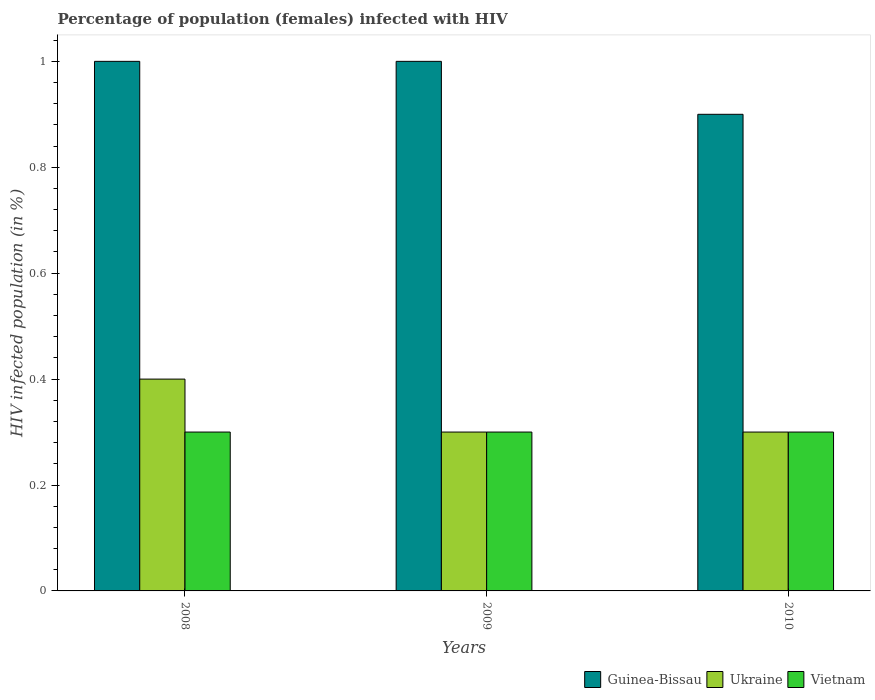How many different coloured bars are there?
Provide a succinct answer. 3. How many groups of bars are there?
Make the answer very short. 3. Are the number of bars per tick equal to the number of legend labels?
Ensure brevity in your answer.  Yes. What is the label of the 1st group of bars from the left?
Your response must be concise. 2008. In how many cases, is the number of bars for a given year not equal to the number of legend labels?
Provide a short and direct response. 0. In which year was the percentage of HIV infected female population in Ukraine maximum?
Offer a very short reply. 2008. What is the total percentage of HIV infected female population in Ukraine in the graph?
Provide a short and direct response. 1. What is the average percentage of HIV infected female population in Ukraine per year?
Offer a very short reply. 0.33. In the year 2009, what is the difference between the percentage of HIV infected female population in Guinea-Bissau and percentage of HIV infected female population in Ukraine?
Offer a terse response. 0.7. What is the ratio of the percentage of HIV infected female population in Guinea-Bissau in 2008 to that in 2009?
Your answer should be very brief. 1. Is the percentage of HIV infected female population in Ukraine in 2008 less than that in 2010?
Your answer should be very brief. No. What is the difference between the highest and the lowest percentage of HIV infected female population in Guinea-Bissau?
Your answer should be compact. 0.1. In how many years, is the percentage of HIV infected female population in Ukraine greater than the average percentage of HIV infected female population in Ukraine taken over all years?
Provide a succinct answer. 1. What does the 3rd bar from the left in 2008 represents?
Ensure brevity in your answer.  Vietnam. What does the 1st bar from the right in 2008 represents?
Your answer should be compact. Vietnam. How many bars are there?
Provide a succinct answer. 9. Are all the bars in the graph horizontal?
Offer a very short reply. No. How many years are there in the graph?
Your response must be concise. 3. What is the difference between two consecutive major ticks on the Y-axis?
Your answer should be very brief. 0.2. Are the values on the major ticks of Y-axis written in scientific E-notation?
Your answer should be compact. No. Does the graph contain any zero values?
Give a very brief answer. No. Does the graph contain grids?
Offer a very short reply. No. Where does the legend appear in the graph?
Offer a very short reply. Bottom right. What is the title of the graph?
Ensure brevity in your answer.  Percentage of population (females) infected with HIV. Does "El Salvador" appear as one of the legend labels in the graph?
Make the answer very short. No. What is the label or title of the X-axis?
Your answer should be compact. Years. What is the label or title of the Y-axis?
Provide a succinct answer. HIV infected population (in %). What is the HIV infected population (in %) of Guinea-Bissau in 2008?
Provide a short and direct response. 1. What is the HIV infected population (in %) of Ukraine in 2008?
Offer a terse response. 0.4. What is the HIV infected population (in %) in Vietnam in 2008?
Give a very brief answer. 0.3. What is the HIV infected population (in %) in Guinea-Bissau in 2009?
Keep it short and to the point. 1. What is the HIV infected population (in %) of Ukraine in 2009?
Your response must be concise. 0.3. What is the HIV infected population (in %) in Guinea-Bissau in 2010?
Your answer should be compact. 0.9. What is the HIV infected population (in %) of Vietnam in 2010?
Your answer should be very brief. 0.3. Across all years, what is the maximum HIV infected population (in %) of Guinea-Bissau?
Ensure brevity in your answer.  1. Across all years, what is the maximum HIV infected population (in %) in Ukraine?
Keep it short and to the point. 0.4. Across all years, what is the maximum HIV infected population (in %) in Vietnam?
Provide a short and direct response. 0.3. Across all years, what is the minimum HIV infected population (in %) of Guinea-Bissau?
Offer a terse response. 0.9. Across all years, what is the minimum HIV infected population (in %) of Vietnam?
Ensure brevity in your answer.  0.3. What is the total HIV infected population (in %) of Guinea-Bissau in the graph?
Keep it short and to the point. 2.9. What is the total HIV infected population (in %) in Ukraine in the graph?
Keep it short and to the point. 1. What is the total HIV infected population (in %) in Vietnam in the graph?
Ensure brevity in your answer.  0.9. What is the difference between the HIV infected population (in %) in Ukraine in 2008 and that in 2009?
Your answer should be very brief. 0.1. What is the difference between the HIV infected population (in %) in Vietnam in 2008 and that in 2009?
Your response must be concise. 0. What is the difference between the HIV infected population (in %) in Vietnam in 2008 and that in 2010?
Your answer should be compact. 0. What is the difference between the HIV infected population (in %) in Guinea-Bissau in 2009 and that in 2010?
Provide a short and direct response. 0.1. What is the difference between the HIV infected population (in %) of Ukraine in 2009 and that in 2010?
Your answer should be compact. 0. What is the difference between the HIV infected population (in %) in Guinea-Bissau in 2008 and the HIV infected population (in %) in Vietnam in 2009?
Your response must be concise. 0.7. What is the difference between the HIV infected population (in %) of Guinea-Bissau in 2009 and the HIV infected population (in %) of Ukraine in 2010?
Give a very brief answer. 0.7. What is the difference between the HIV infected population (in %) in Guinea-Bissau in 2009 and the HIV infected population (in %) in Vietnam in 2010?
Your response must be concise. 0.7. What is the difference between the HIV infected population (in %) in Ukraine in 2009 and the HIV infected population (in %) in Vietnam in 2010?
Give a very brief answer. 0. What is the average HIV infected population (in %) in Guinea-Bissau per year?
Your answer should be compact. 0.97. What is the average HIV infected population (in %) of Vietnam per year?
Your response must be concise. 0.3. In the year 2008, what is the difference between the HIV infected population (in %) in Ukraine and HIV infected population (in %) in Vietnam?
Offer a very short reply. 0.1. In the year 2009, what is the difference between the HIV infected population (in %) of Guinea-Bissau and HIV infected population (in %) of Ukraine?
Keep it short and to the point. 0.7. In the year 2009, what is the difference between the HIV infected population (in %) of Ukraine and HIV infected population (in %) of Vietnam?
Give a very brief answer. 0. In the year 2010, what is the difference between the HIV infected population (in %) in Guinea-Bissau and HIV infected population (in %) in Ukraine?
Give a very brief answer. 0.6. What is the ratio of the HIV infected population (in %) of Guinea-Bissau in 2008 to that in 2009?
Ensure brevity in your answer.  1. What is the ratio of the HIV infected population (in %) of Ukraine in 2008 to that in 2009?
Provide a succinct answer. 1.33. What is the ratio of the HIV infected population (in %) of Vietnam in 2008 to that in 2009?
Make the answer very short. 1. What is the ratio of the HIV infected population (in %) of Guinea-Bissau in 2008 to that in 2010?
Offer a very short reply. 1.11. What is the ratio of the HIV infected population (in %) of Vietnam in 2008 to that in 2010?
Give a very brief answer. 1. What is the ratio of the HIV infected population (in %) of Guinea-Bissau in 2009 to that in 2010?
Offer a terse response. 1.11. What is the ratio of the HIV infected population (in %) of Vietnam in 2009 to that in 2010?
Provide a short and direct response. 1. What is the difference between the highest and the second highest HIV infected population (in %) of Guinea-Bissau?
Your answer should be very brief. 0. What is the difference between the highest and the second highest HIV infected population (in %) of Ukraine?
Your answer should be very brief. 0.1. What is the difference between the highest and the second highest HIV infected population (in %) in Vietnam?
Your answer should be very brief. 0. What is the difference between the highest and the lowest HIV infected population (in %) in Vietnam?
Provide a short and direct response. 0. 